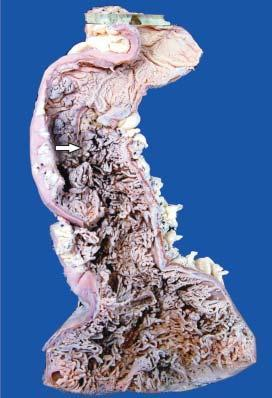what is the mucosal surface straddled with?
Answer the question using a single word or phrase. Multiple polyoid structures of varying sizes 